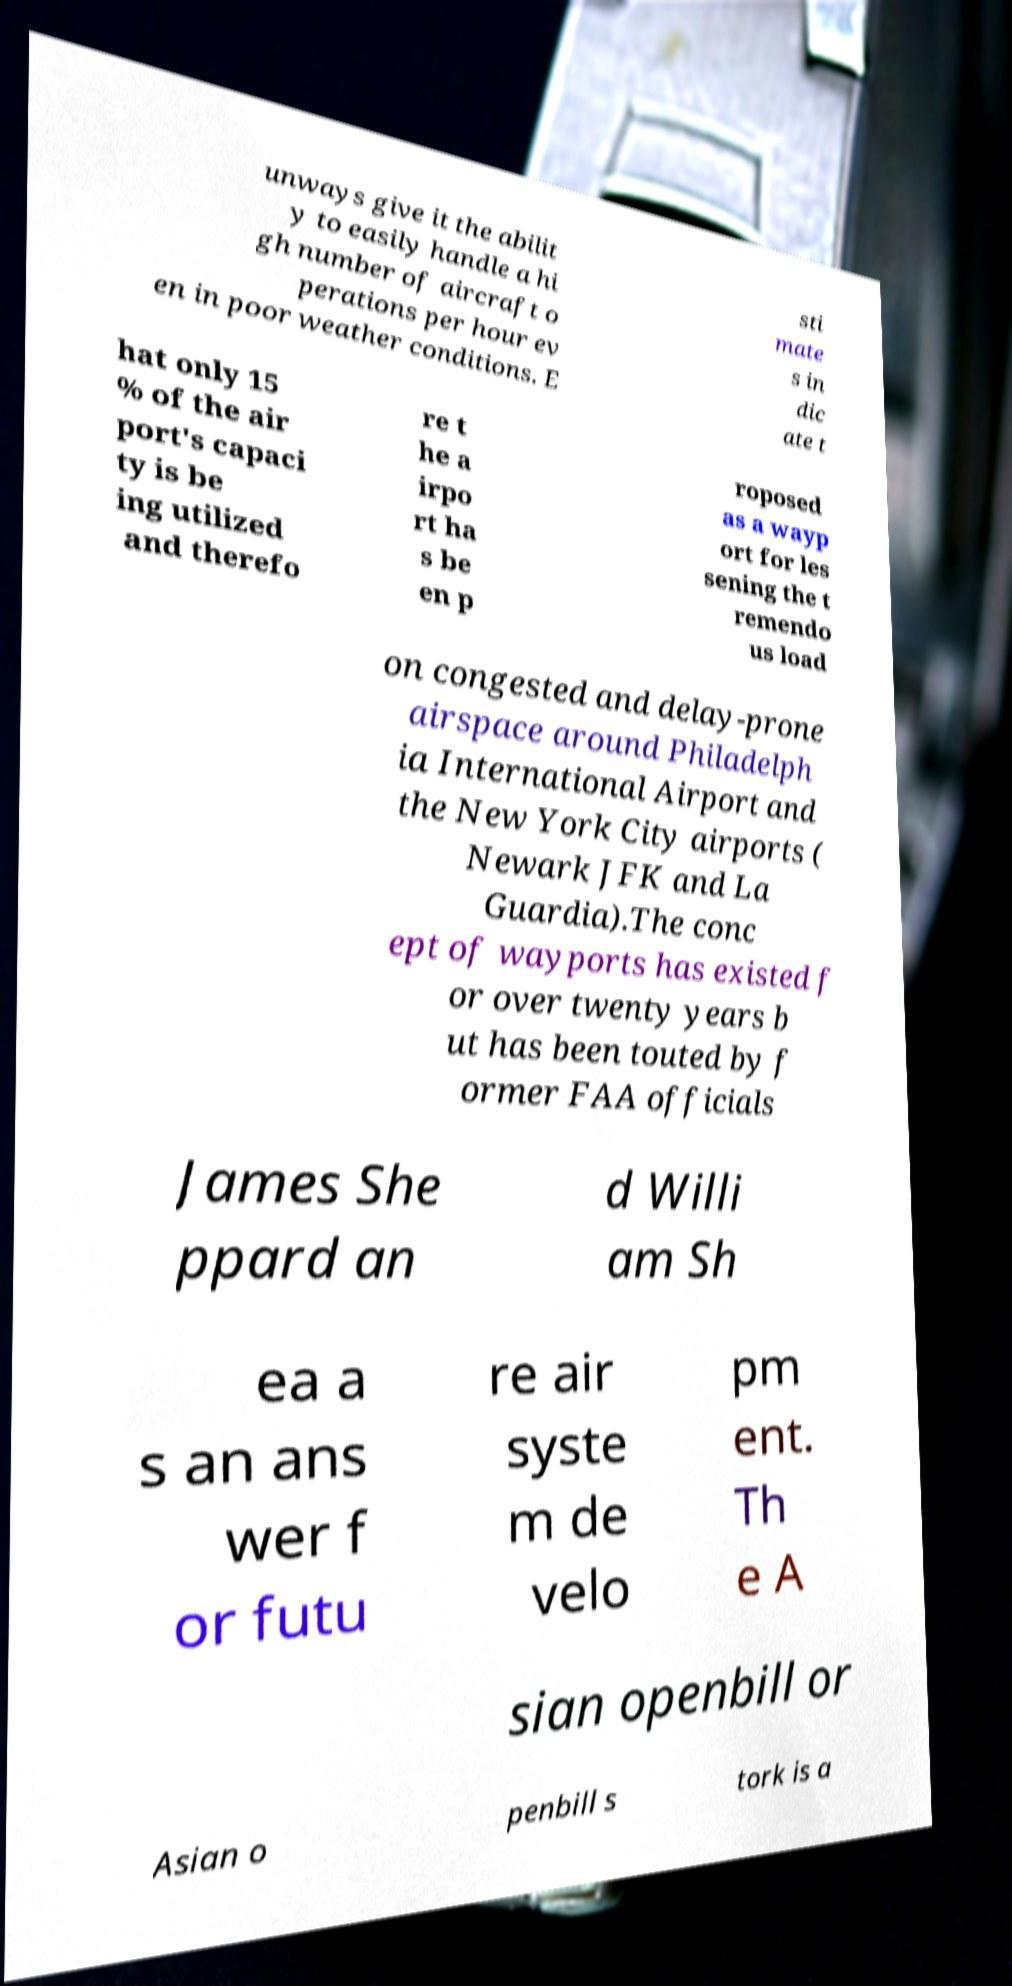Could you extract and type out the text from this image? unways give it the abilit y to easily handle a hi gh number of aircraft o perations per hour ev en in poor weather conditions. E sti mate s in dic ate t hat only 15 % of the air port's capaci ty is be ing utilized and therefo re t he a irpo rt ha s be en p roposed as a wayp ort for les sening the t remendo us load on congested and delay-prone airspace around Philadelph ia International Airport and the New York City airports ( Newark JFK and La Guardia).The conc ept of wayports has existed f or over twenty years b ut has been touted by f ormer FAA officials James She ppard an d Willi am Sh ea a s an ans wer f or futu re air syste m de velo pm ent. Th e A sian openbill or Asian o penbill s tork is a 